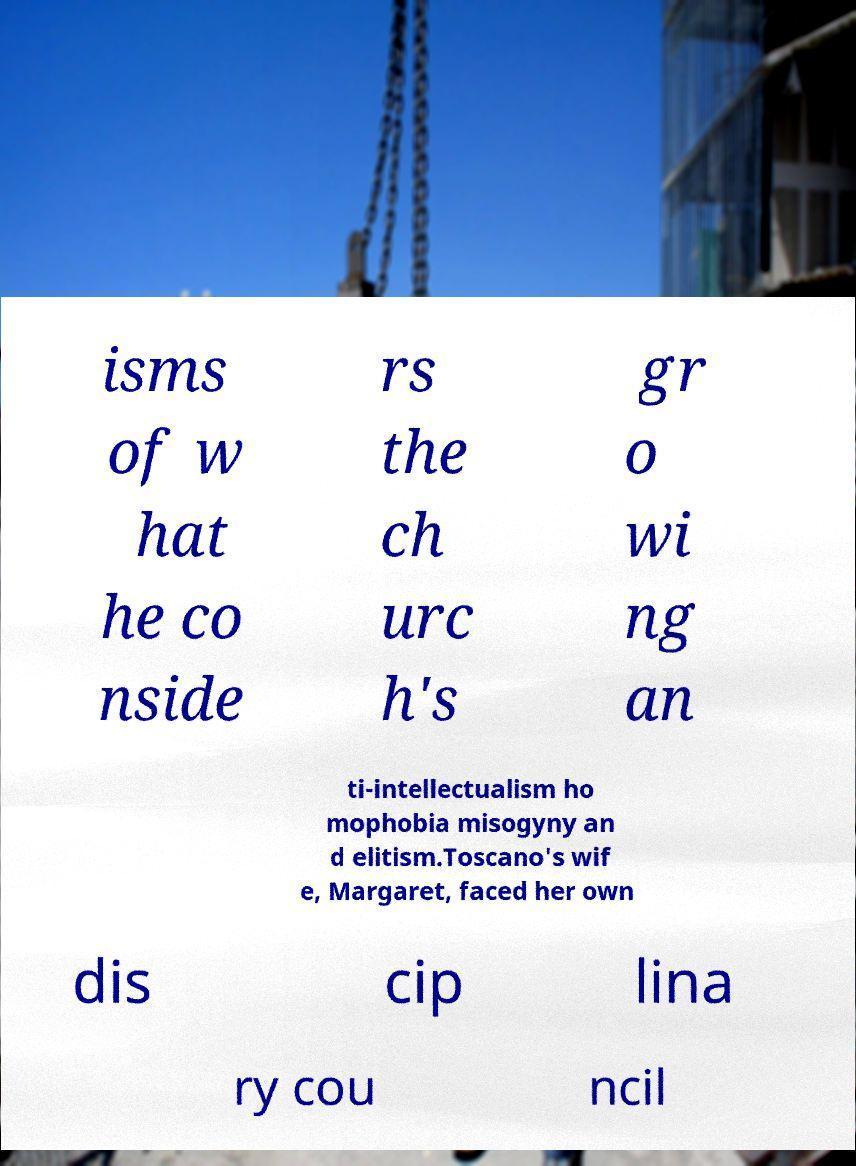I need the written content from this picture converted into text. Can you do that? isms of w hat he co nside rs the ch urc h's gr o wi ng an ti-intellectualism ho mophobia misogyny an d elitism.Toscano's wif e, Margaret, faced her own dis cip lina ry cou ncil 